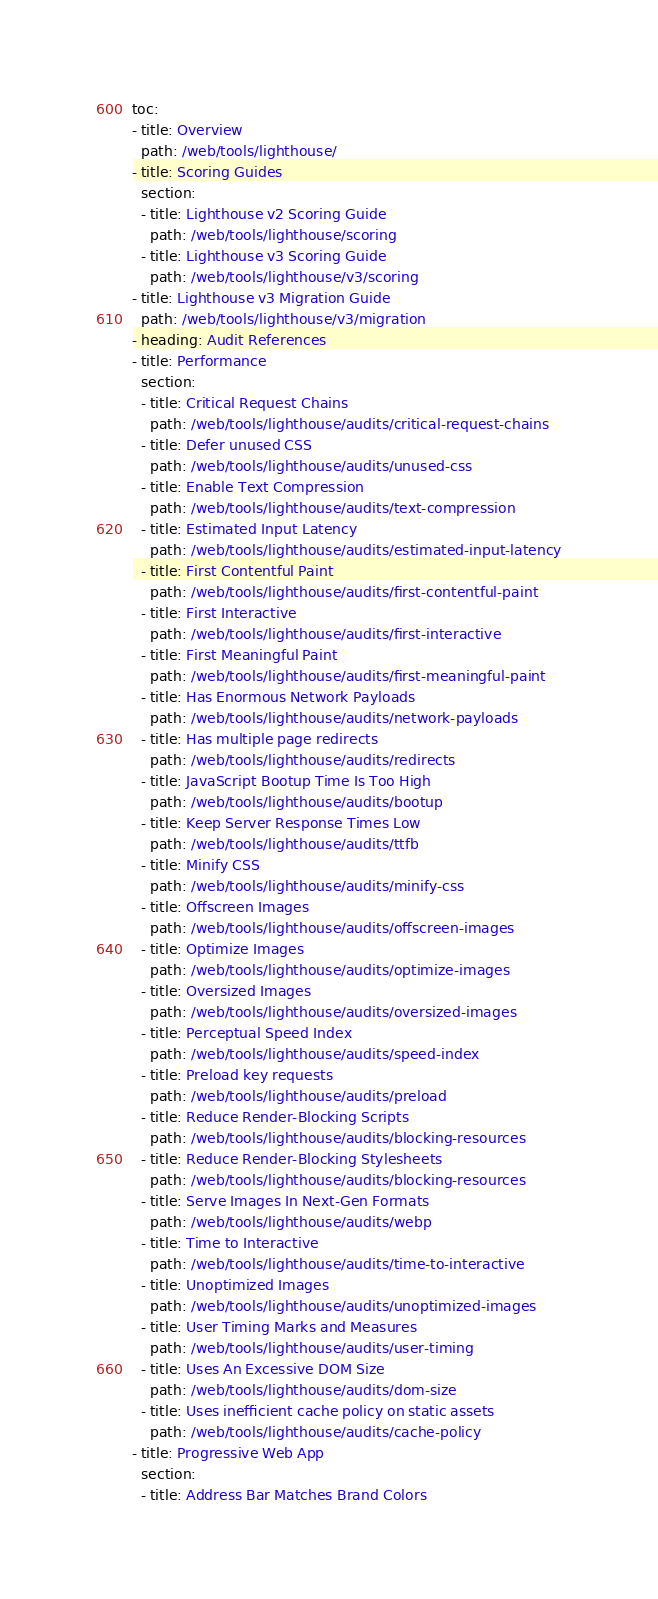<code> <loc_0><loc_0><loc_500><loc_500><_YAML_>toc:
- title: Overview
  path: /web/tools/lighthouse/
- title: Scoring Guides
  section:
  - title: Lighthouse v2 Scoring Guide
    path: /web/tools/lighthouse/scoring
  - title: Lighthouse v3 Scoring Guide
    path: /web/tools/lighthouse/v3/scoring
- title: Lighthouse v3 Migration Guide
  path: /web/tools/lighthouse/v3/migration
- heading: Audit References
- title: Performance
  section:
  - title: Critical Request Chains
    path: /web/tools/lighthouse/audits/critical-request-chains
  - title: Defer unused CSS
    path: /web/tools/lighthouse/audits/unused-css
  - title: Enable Text Compression
    path: /web/tools/lighthouse/audits/text-compression
  - title: Estimated Input Latency
    path: /web/tools/lighthouse/audits/estimated-input-latency
  - title: First Contentful Paint
    path: /web/tools/lighthouse/audits/first-contentful-paint
  - title: First Interactive
    path: /web/tools/lighthouse/audits/first-interactive
  - title: First Meaningful Paint
    path: /web/tools/lighthouse/audits/first-meaningful-paint
  - title: Has Enormous Network Payloads
    path: /web/tools/lighthouse/audits/network-payloads
  - title: Has multiple page redirects
    path: /web/tools/lighthouse/audits/redirects
  - title: JavaScript Bootup Time Is Too High
    path: /web/tools/lighthouse/audits/bootup
  - title: Keep Server Response Times Low
    path: /web/tools/lighthouse/audits/ttfb
  - title: Minify CSS
    path: /web/tools/lighthouse/audits/minify-css
  - title: Offscreen Images
    path: /web/tools/lighthouse/audits/offscreen-images
  - title: Optimize Images
    path: /web/tools/lighthouse/audits/optimize-images
  - title: Oversized Images
    path: /web/tools/lighthouse/audits/oversized-images
  - title: Perceptual Speed Index
    path: /web/tools/lighthouse/audits/speed-index
  - title: Preload key requests
    path: /web/tools/lighthouse/audits/preload
  - title: Reduce Render-Blocking Scripts
    path: /web/tools/lighthouse/audits/blocking-resources
  - title: Reduce Render-Blocking Stylesheets
    path: /web/tools/lighthouse/audits/blocking-resources
  - title: Serve Images In Next-Gen Formats
    path: /web/tools/lighthouse/audits/webp
  - title: Time to Interactive
    path: /web/tools/lighthouse/audits/time-to-interactive
  - title: Unoptimized Images
    path: /web/tools/lighthouse/audits/unoptimized-images
  - title: User Timing Marks and Measures
    path: /web/tools/lighthouse/audits/user-timing
  - title: Uses An Excessive DOM Size
    path: /web/tools/lighthouse/audits/dom-size
  - title: Uses inefficient cache policy on static assets
    path: /web/tools/lighthouse/audits/cache-policy
- title: Progressive Web App
  section:
  - title: Address Bar Matches Brand Colors</code> 